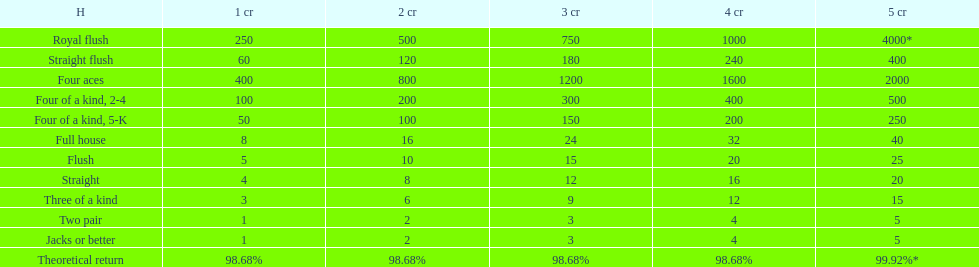The number of credits returned for a one credit bet on a royal flush are. 250. 